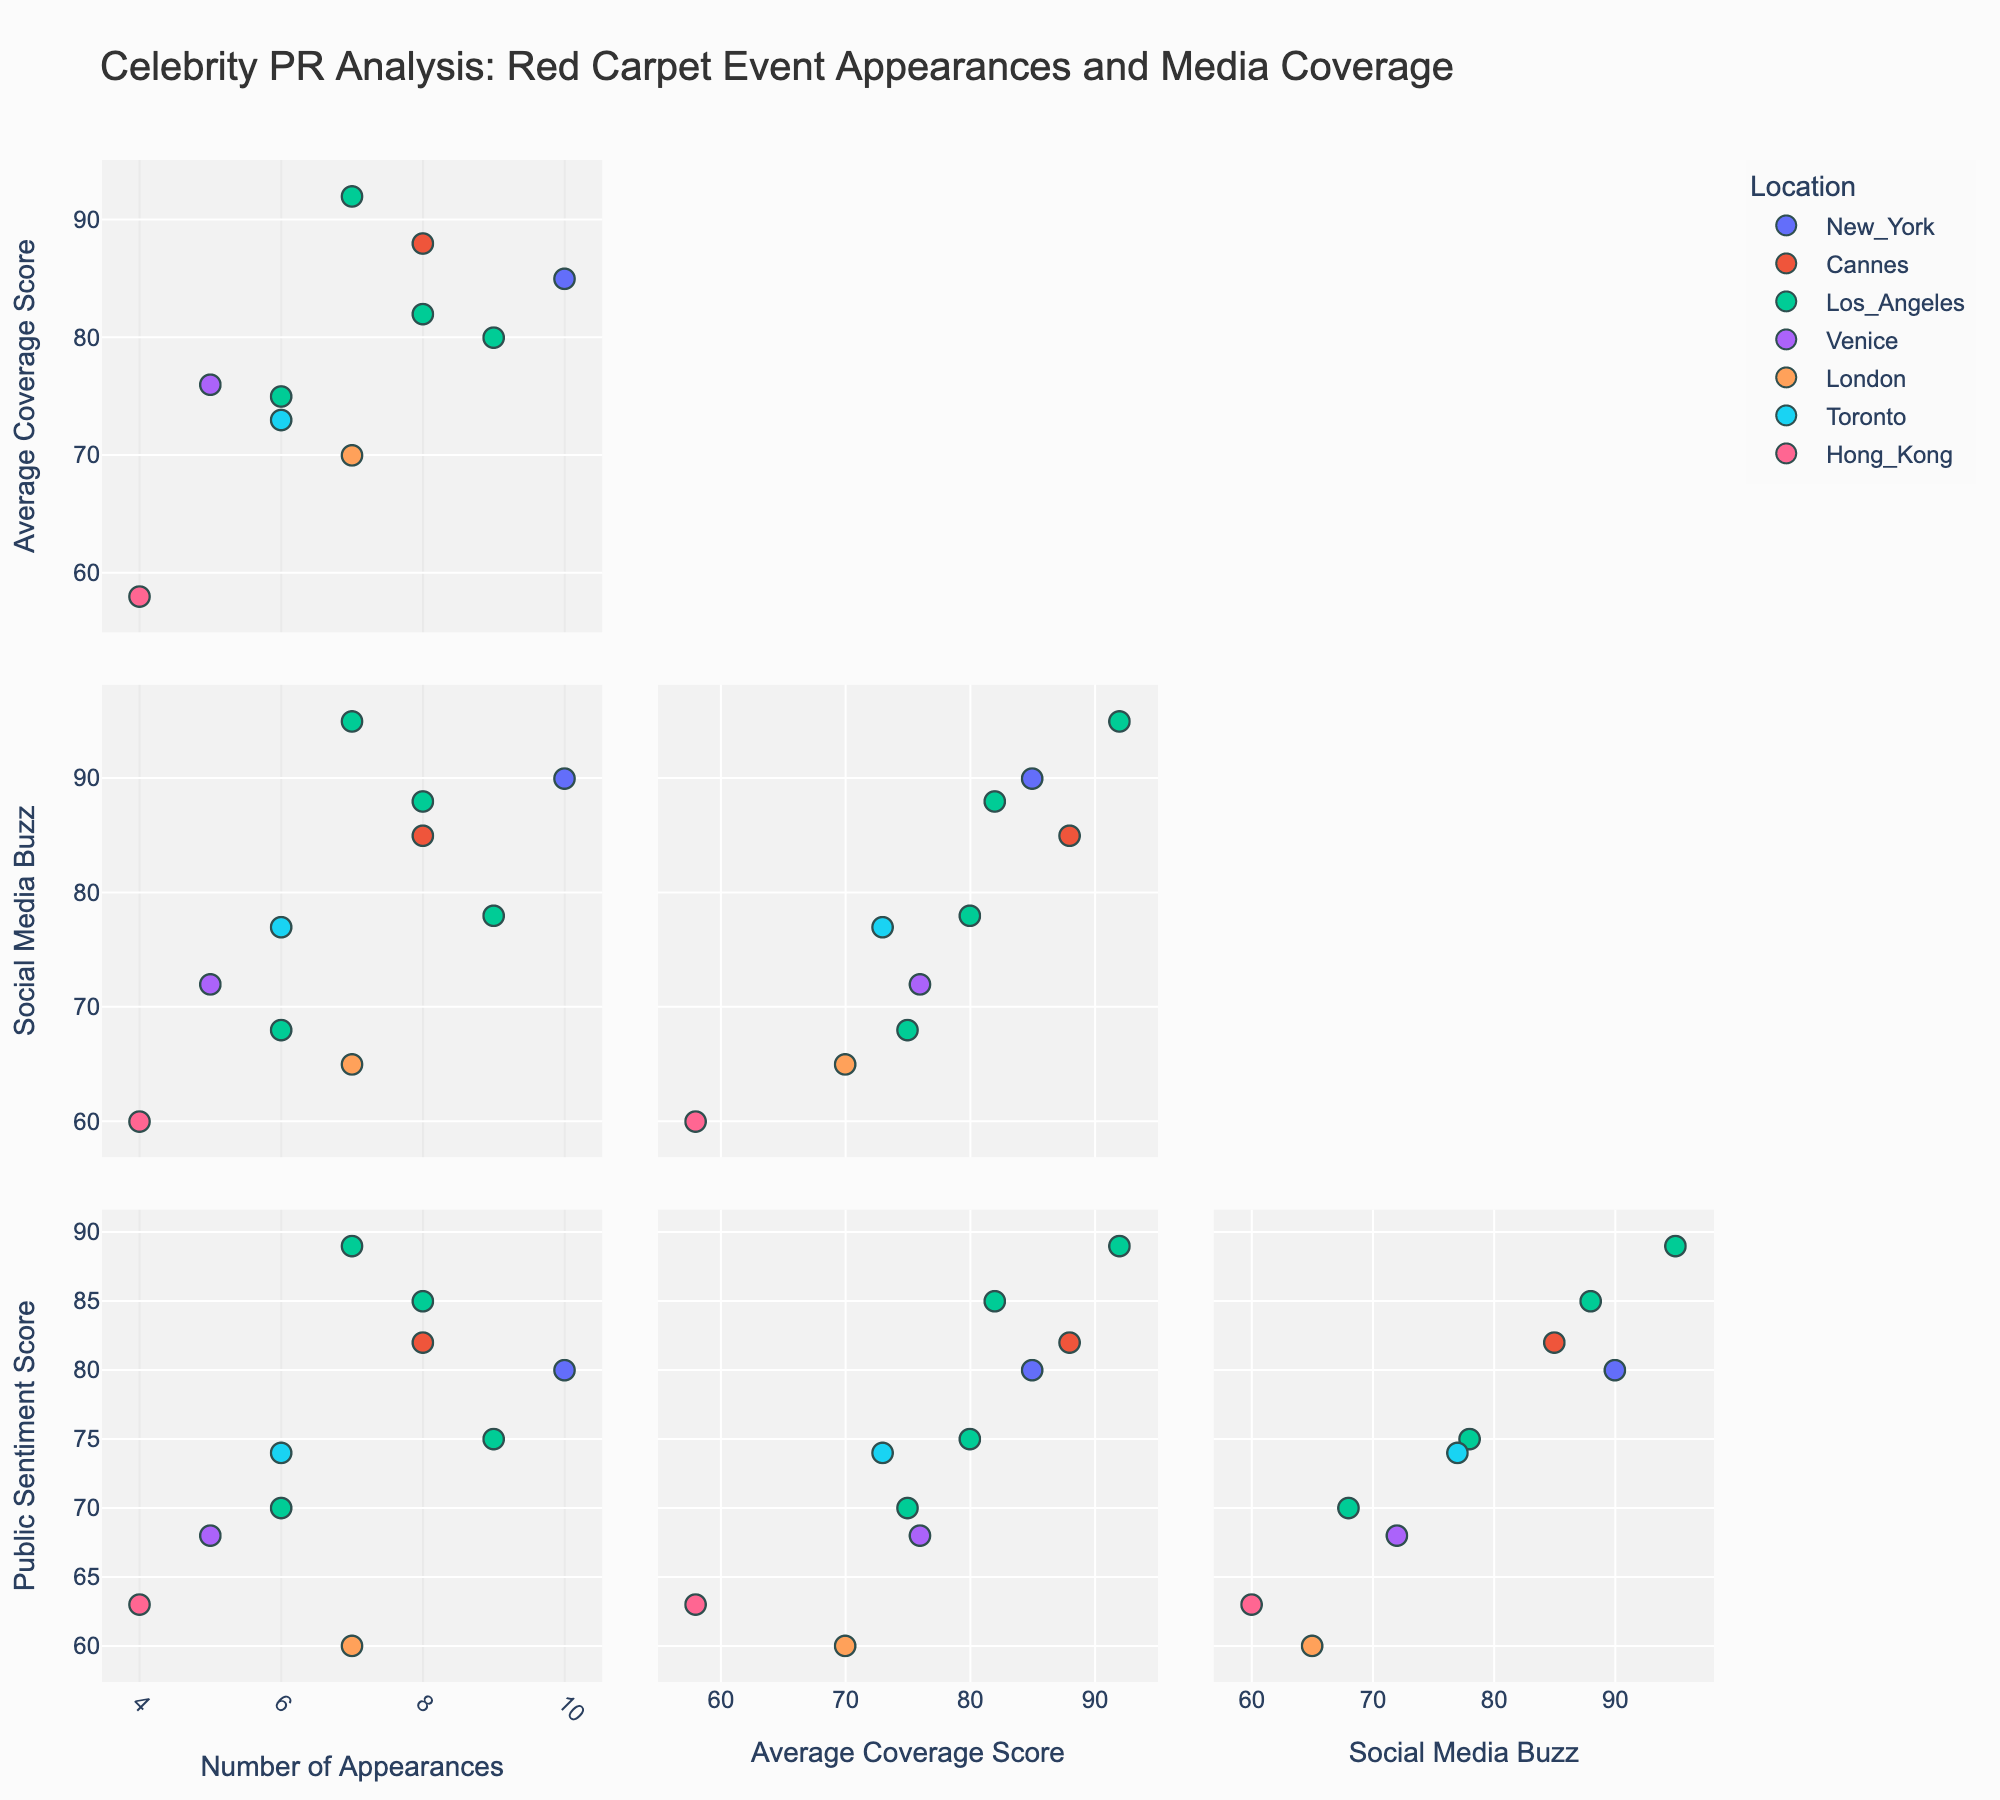What is the title of the figure? The title is typically located at the top of the figure. Looking at the figure, the title reads "Celebrity PR Analysis: Red Carpet Event Appearances and Media Coverage"
Answer: Celebrity PR Analysis: Red Carpet Event Appearances and Media Coverage How many dimensions are compared in this SPLOM? Dimensions in a SPLOM are typically indicated by the different axes in the scatter plots. By checking the axis labels, we can see four dimensions: 'Number of Appearances', 'Average Coverage Score', 'Social Media Buzz', and 'Public Sentiment Score'
Answer: Four Which location has the most consistent appearance across the different metrics? To determine consistency, observe the clustering of points for each location. By visual inspection, New York (representing Met Gala with 10 appearances) shows closely clustered points across various metrics, indicating consistency
Answer: New York Compare the average coverage scores between the events in Los Angeles. Which event has the highest score and how much higher is it than the others? Identify the events held in Los Angeles and check their average coverage scores. Oscars (92), Golden Globes (80), BAFTA LA (75), Grammy Awards (82). The Oscars score highest at 92. Comparing this with others: Oscars is 12 points higher than Golden Globes (92-80), 17 higher than BAFTA LA (92-75), and 10 higher than Grammy Awards (92-82)
Answer: Oscars, 10 points (compared to Grammy Awards) Which event had the highest social media buzz? Locate the highest value on the Social Media Buzz axis. The Oscars in Los Angeles have the highest social media buzz with a score of 95
Answer: Oscars in Los Angeles Do events with higher appearances seem to have higher public sentiment scores? Visually observe the correlation between 'Number of Appearances' and 'Public Sentiment Score'. Many points with higher appearances also show higher sentiment scores, suggesting a positive correlation
Answer: Yes What’s the difference in the average coverage score between Cannes Film Festival and Venice Film Festival? Note the average coverage score for Cannes Film Festival (88) and Venice Film Festival (76). Then subtract the smaller value from the larger value: 88 - 76 = 12
Answer: 12 For the two locations with the highest average coverage scores, which one has the higher public sentiment score? Check highest average coverage scores (Oscars in Los Angeles with 92, Cannes Film Festival with 88). Compare their public sentiment scores, (Oscars 89 vs. Cannes 82). Oscars in Los Angeles has the higher public sentiment score
Answer: Oscars in Los Angeles Which event in Los Angeles had the lowest public sentiment score and what was the score? Reviewing public sentiment scores for Los Angeles events, BAFTA LA has the lowest score of 70
Answer: BAFTA LA, 70 Is there a specific location that has more diversity in the number of appearances compared to others? Diversity can be observed by the spread of data points on the 'Number of Appearances' axis. Los Angeles shows most diverse range (having events with appearances from 6 to 9)
Answer: Los Angeles 